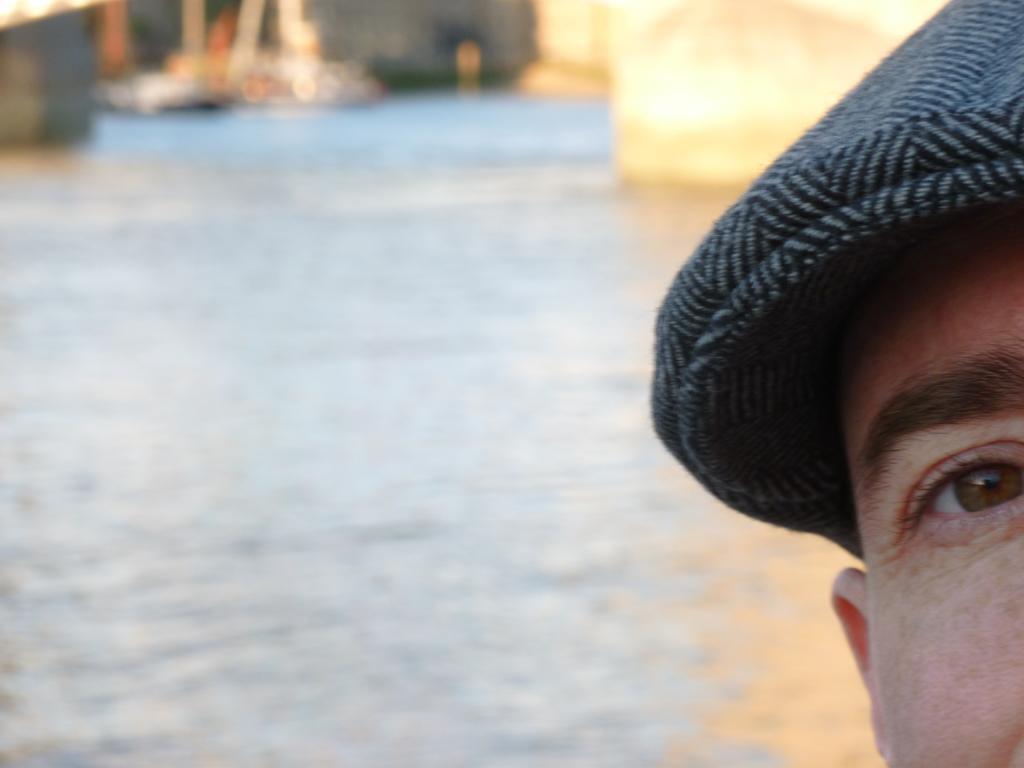Describe this image in one or two sentences. In the picture there is water, there is a person wearing cap. 